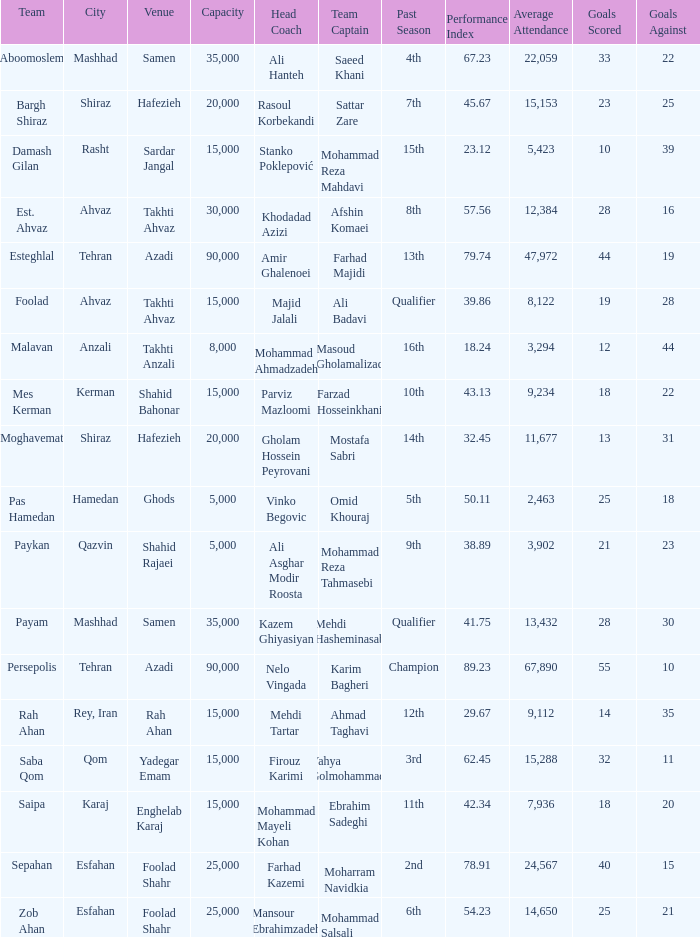What is the Capacity of the Venue of Head Coach Ali Asghar Modir Roosta? 5000.0. 